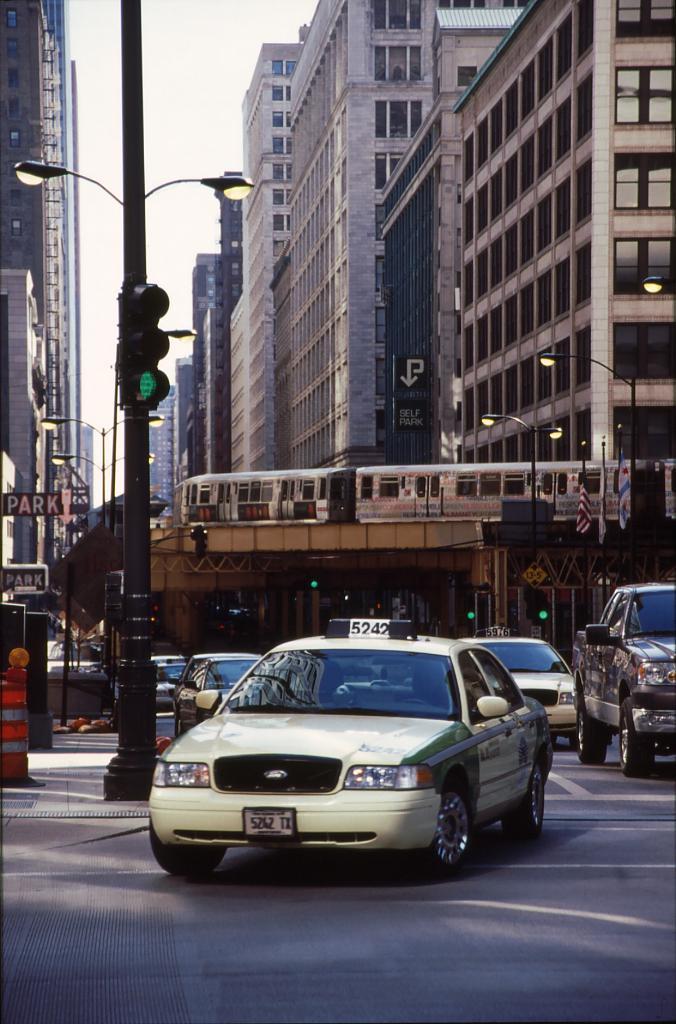What text can you see?
Your answer should be compact. 5242. What modes of transportation do you see?
Ensure brevity in your answer.  Taxi. 